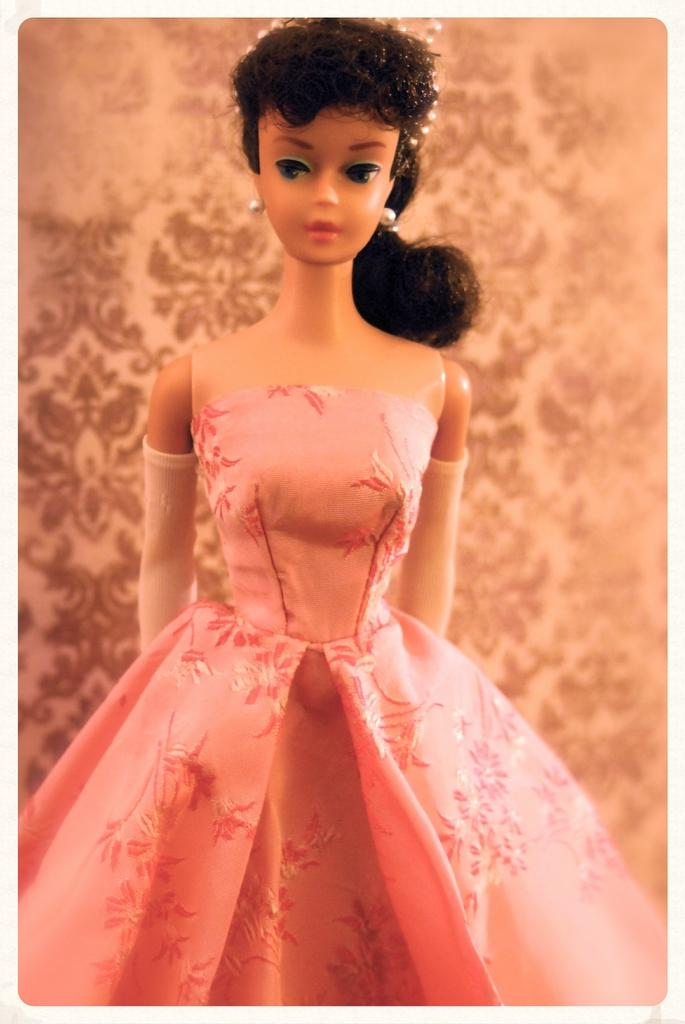What is the main subject in the center of the image? There is a doll in the center of the image. How is the doll dressed? The doll has a different costume. What can be seen in the background of the image? There is a wall with a design in the background of the image. Can you see a crown on the doll's head in the image? There is no crown visible on the doll's head in the image. What type of shirt is the family wearing in the image? There is no family present in the image, only the doll. 